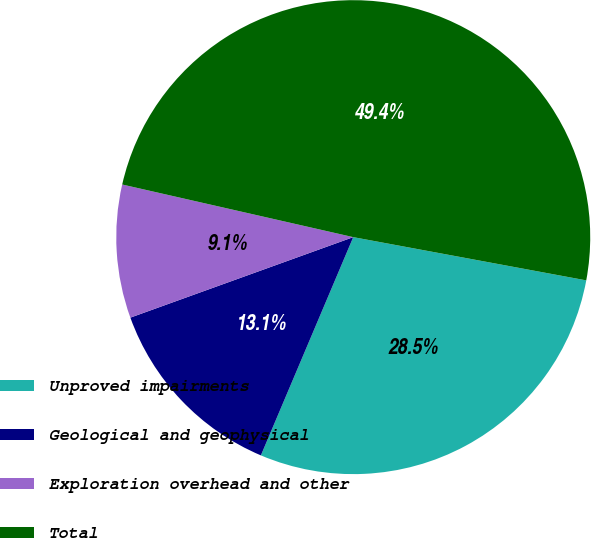Convert chart to OTSL. <chart><loc_0><loc_0><loc_500><loc_500><pie_chart><fcel>Unproved impairments<fcel>Geological and geophysical<fcel>Exploration overhead and other<fcel>Total<nl><fcel>28.45%<fcel>13.11%<fcel>9.08%<fcel>49.35%<nl></chart> 